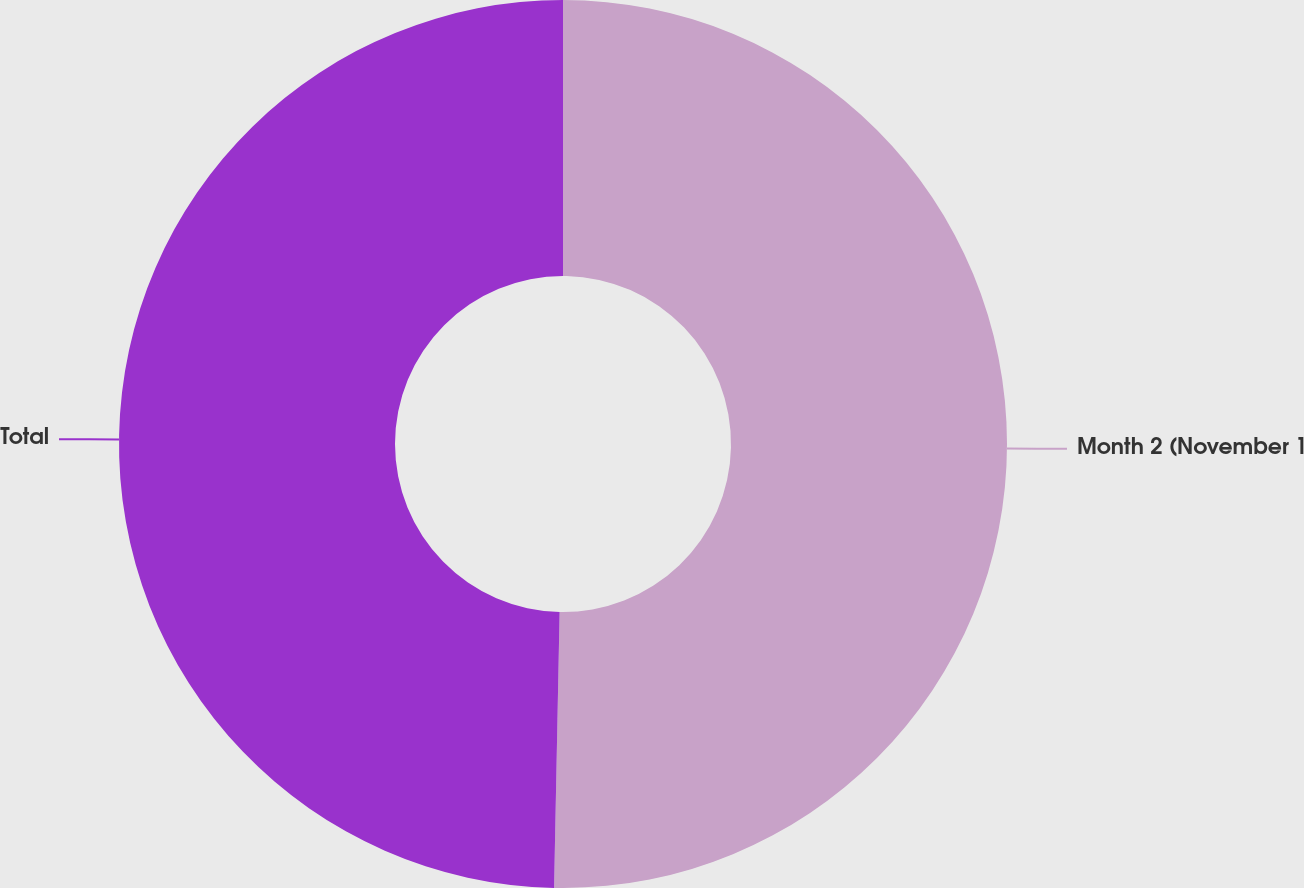Convert chart to OTSL. <chart><loc_0><loc_0><loc_500><loc_500><pie_chart><fcel>Month 2 (November 1<fcel>Total<nl><fcel>50.32%<fcel>49.68%<nl></chart> 